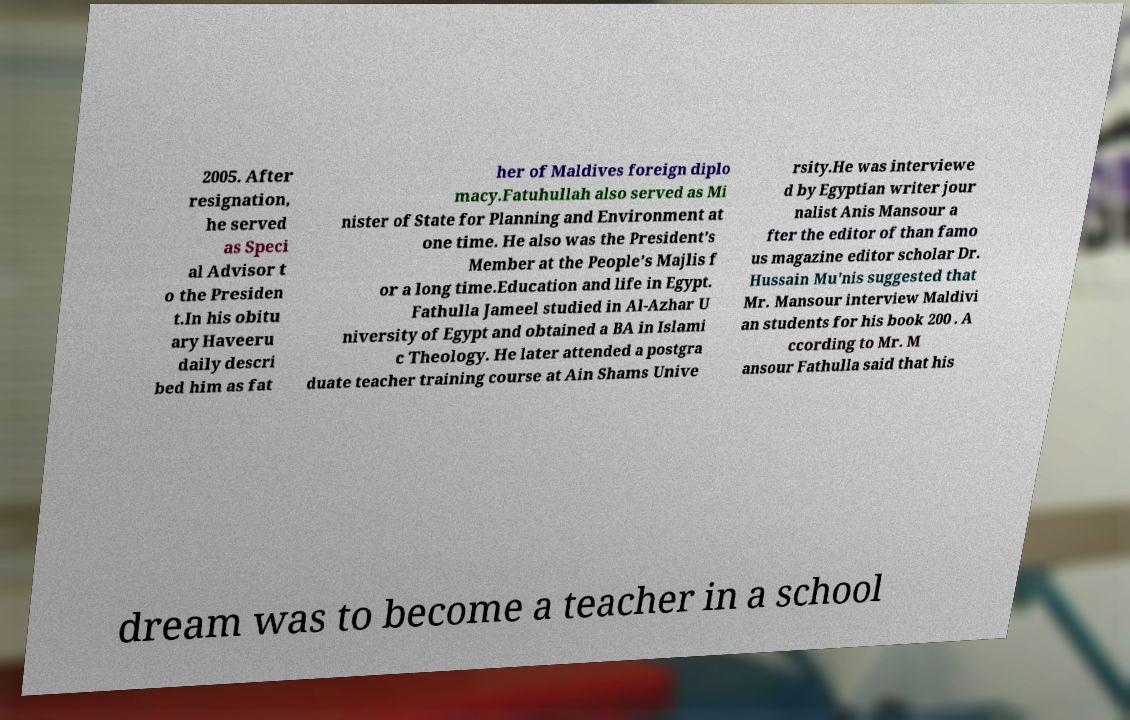Could you extract and type out the text from this image? 2005. After resignation, he served as Speci al Advisor t o the Presiden t.In his obitu ary Haveeru daily descri bed him as fat her of Maldives foreign diplo macy.Fatuhullah also served as Mi nister of State for Planning and Environment at one time. He also was the President’s Member at the People’s Majlis f or a long time.Education and life in Egypt. Fathulla Jameel studied in Al-Azhar U niversity of Egypt and obtained a BA in Islami c Theology. He later attended a postgra duate teacher training course at Ain Shams Unive rsity.He was interviewe d by Egyptian writer jour nalist Anis Mansour a fter the editor of than famo us magazine editor scholar Dr. Hussain Mu'nis suggested that Mr. Mansour interview Maldivi an students for his book 200 . A ccording to Mr. M ansour Fathulla said that his dream was to become a teacher in a school 